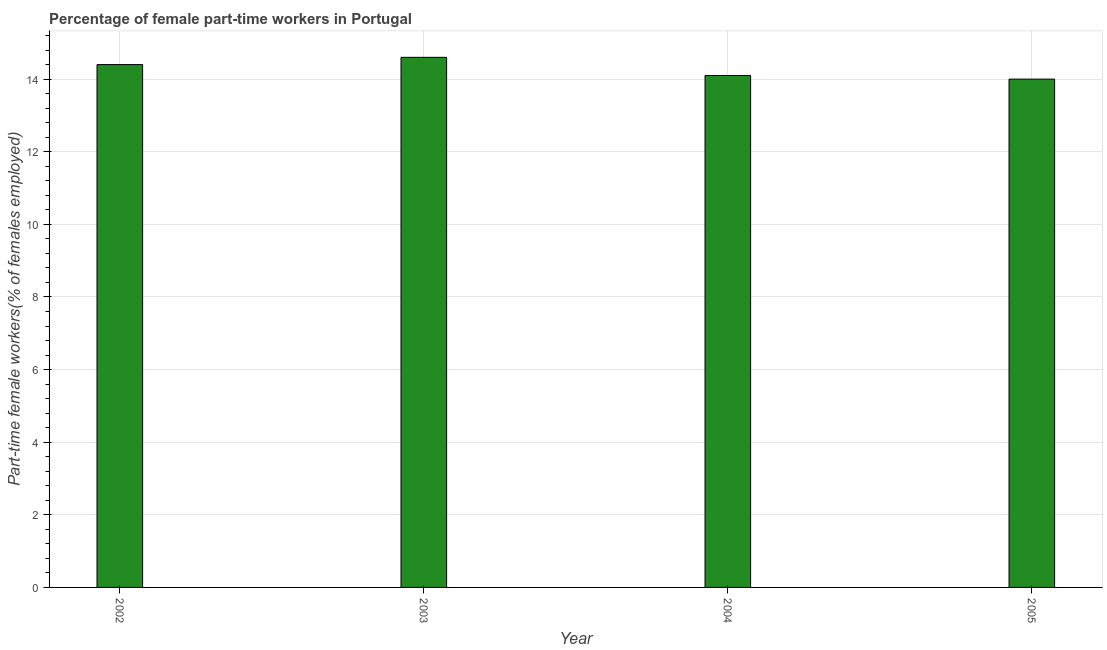Does the graph contain any zero values?
Provide a succinct answer. No. Does the graph contain grids?
Your answer should be compact. Yes. What is the title of the graph?
Keep it short and to the point. Percentage of female part-time workers in Portugal. What is the label or title of the Y-axis?
Provide a succinct answer. Part-time female workers(% of females employed). What is the percentage of part-time female workers in 2005?
Keep it short and to the point. 14. Across all years, what is the maximum percentage of part-time female workers?
Your answer should be compact. 14.6. Across all years, what is the minimum percentage of part-time female workers?
Provide a short and direct response. 14. In which year was the percentage of part-time female workers maximum?
Give a very brief answer. 2003. What is the sum of the percentage of part-time female workers?
Make the answer very short. 57.1. What is the average percentage of part-time female workers per year?
Your answer should be compact. 14.28. What is the median percentage of part-time female workers?
Your answer should be compact. 14.25. Do a majority of the years between 2004 and 2005 (inclusive) have percentage of part-time female workers greater than 6 %?
Offer a terse response. Yes. Is the percentage of part-time female workers in 2003 less than that in 2005?
Make the answer very short. No. Is the sum of the percentage of part-time female workers in 2003 and 2004 greater than the maximum percentage of part-time female workers across all years?
Keep it short and to the point. Yes. In how many years, is the percentage of part-time female workers greater than the average percentage of part-time female workers taken over all years?
Provide a short and direct response. 2. How many bars are there?
Your answer should be very brief. 4. What is the difference between two consecutive major ticks on the Y-axis?
Offer a terse response. 2. What is the Part-time female workers(% of females employed) in 2002?
Keep it short and to the point. 14.4. What is the Part-time female workers(% of females employed) of 2003?
Provide a succinct answer. 14.6. What is the Part-time female workers(% of females employed) in 2004?
Your response must be concise. 14.1. What is the difference between the Part-time female workers(% of females employed) in 2002 and 2003?
Your answer should be very brief. -0.2. What is the difference between the Part-time female workers(% of females employed) in 2003 and 2005?
Keep it short and to the point. 0.6. What is the difference between the Part-time female workers(% of females employed) in 2004 and 2005?
Keep it short and to the point. 0.1. What is the ratio of the Part-time female workers(% of females employed) in 2002 to that in 2004?
Provide a succinct answer. 1.02. What is the ratio of the Part-time female workers(% of females employed) in 2002 to that in 2005?
Your response must be concise. 1.03. What is the ratio of the Part-time female workers(% of females employed) in 2003 to that in 2004?
Offer a very short reply. 1.03. What is the ratio of the Part-time female workers(% of females employed) in 2003 to that in 2005?
Your response must be concise. 1.04. 